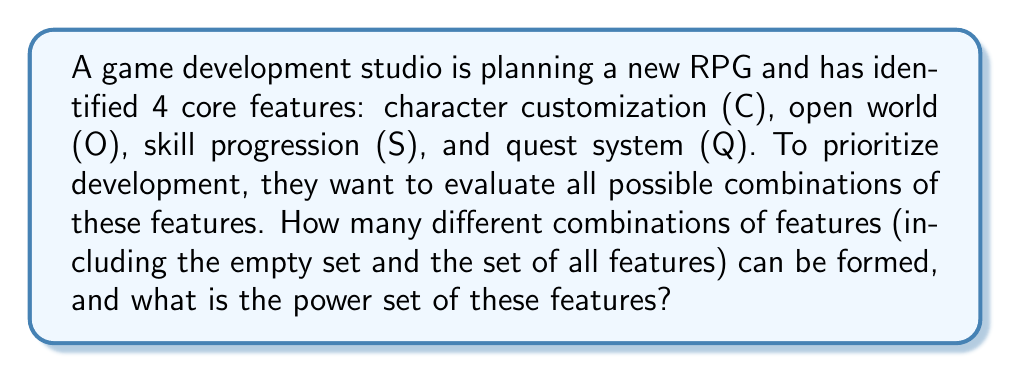What is the answer to this math problem? To solve this problem, we need to understand the concept of a power set and how to calculate it.

1) The power set of a set S is the set of all subsets of S, including the empty set and S itself.

2) For a set with n elements, the number of subsets in its power set is $2^n$.

3) In this case, we have 4 features: C, O, S, and Q. So, n = 4.

4) The number of subsets in the power set will be:
   $2^4 = 16$

5) To list all the subsets in the power set, we can systematically generate them:

   - Empty set: $\{\}$
   - Single element sets: $\{C\}, \{O\}, \{S\}, \{Q\}$
   - Two element sets: $\{C,O\}, \{C,S\}, \{C,Q\}, \{O,S\}, \{O,Q\}, \{S,Q\}$
   - Three element sets: $\{C,O,S\}, \{C,O,Q\}, \{C,S,Q\}, \{O,S,Q\}$
   - Full set: $\{C,O,S,Q\}$

6) The power set P(F), where F is the set of features, is the set containing all these subsets:

   $$P(F) = \{\{\}, \{C\}, \{O\}, \{S\}, \{Q\}, \{C,O\}, \{C,S\}, \{C,Q\}, \{O,S\}, \{O,Q\}, \{S,Q\}, \{C,O,S\}, \{C,O,Q\}, \{C,S,Q\}, \{O,S,Q\}, \{C,O,S,Q\}\}$$

This power set represents all possible combinations of features the studio can consider for development priorities.
Answer: There are 16 different combinations of features, and the power set is:
$$P(F) = \{\{\}, \{C\}, \{O\}, \{S\}, \{Q\}, \{C,O\}, \{C,S\}, \{C,Q\}, \{O,S\}, \{O,Q\}, \{S,Q\}, \{C,O,S\}, \{C,O,Q\}, \{C,S,Q\}, \{O,S,Q\}, \{C,O,S,Q\}\}$$ 